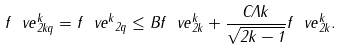Convert formula to latex. <formula><loc_0><loc_0><loc_500><loc_500>\| f _ { \ } v e \| _ { 2 k q } ^ { k } = \| f _ { \ } v e ^ { k } \| _ { 2 q } \leq B \| f _ { \ } v e \| _ { 2 k } ^ { k } + \frac { C \Lambda k } { \sqrt { 2 k - 1 } } \| f _ { \ } v e \| _ { 2 k } ^ { k } .</formula> 